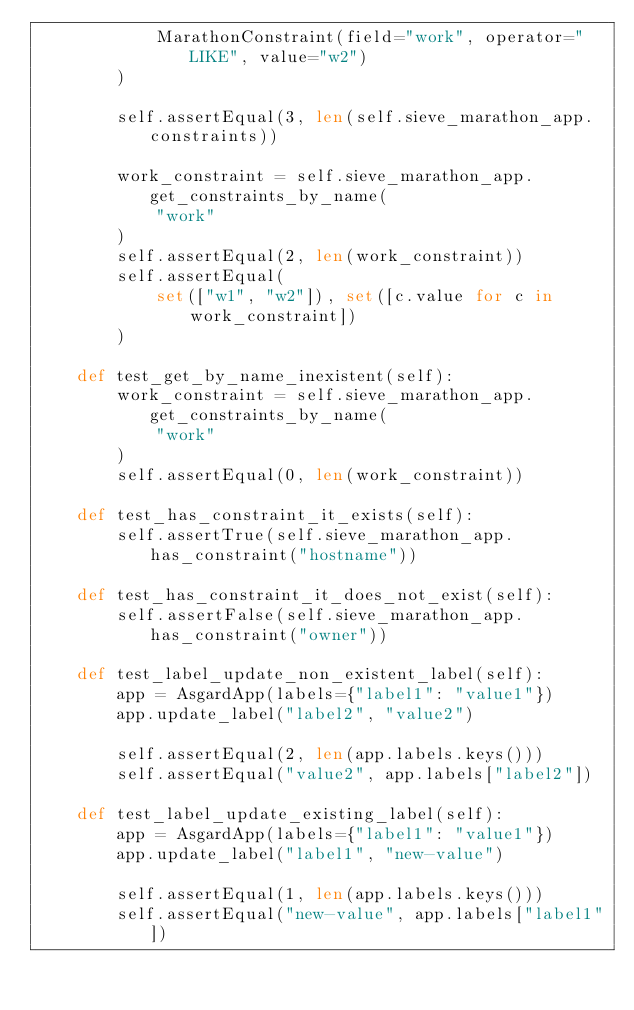Convert code to text. <code><loc_0><loc_0><loc_500><loc_500><_Python_>            MarathonConstraint(field="work", operator="LIKE", value="w2")
        )

        self.assertEqual(3, len(self.sieve_marathon_app.constraints))

        work_constraint = self.sieve_marathon_app.get_constraints_by_name(
            "work"
        )
        self.assertEqual(2, len(work_constraint))
        self.assertEqual(
            set(["w1", "w2"]), set([c.value for c in work_constraint])
        )

    def test_get_by_name_inexistent(self):
        work_constraint = self.sieve_marathon_app.get_constraints_by_name(
            "work"
        )
        self.assertEqual(0, len(work_constraint))

    def test_has_constraint_it_exists(self):
        self.assertTrue(self.sieve_marathon_app.has_constraint("hostname"))

    def test_has_constraint_it_does_not_exist(self):
        self.assertFalse(self.sieve_marathon_app.has_constraint("owner"))

    def test_label_update_non_existent_label(self):
        app = AsgardApp(labels={"label1": "value1"})
        app.update_label("label2", "value2")

        self.assertEqual(2, len(app.labels.keys()))
        self.assertEqual("value2", app.labels["label2"])

    def test_label_update_existing_label(self):
        app = AsgardApp(labels={"label1": "value1"})
        app.update_label("label1", "new-value")

        self.assertEqual(1, len(app.labels.keys()))
        self.assertEqual("new-value", app.labels["label1"])
</code> 